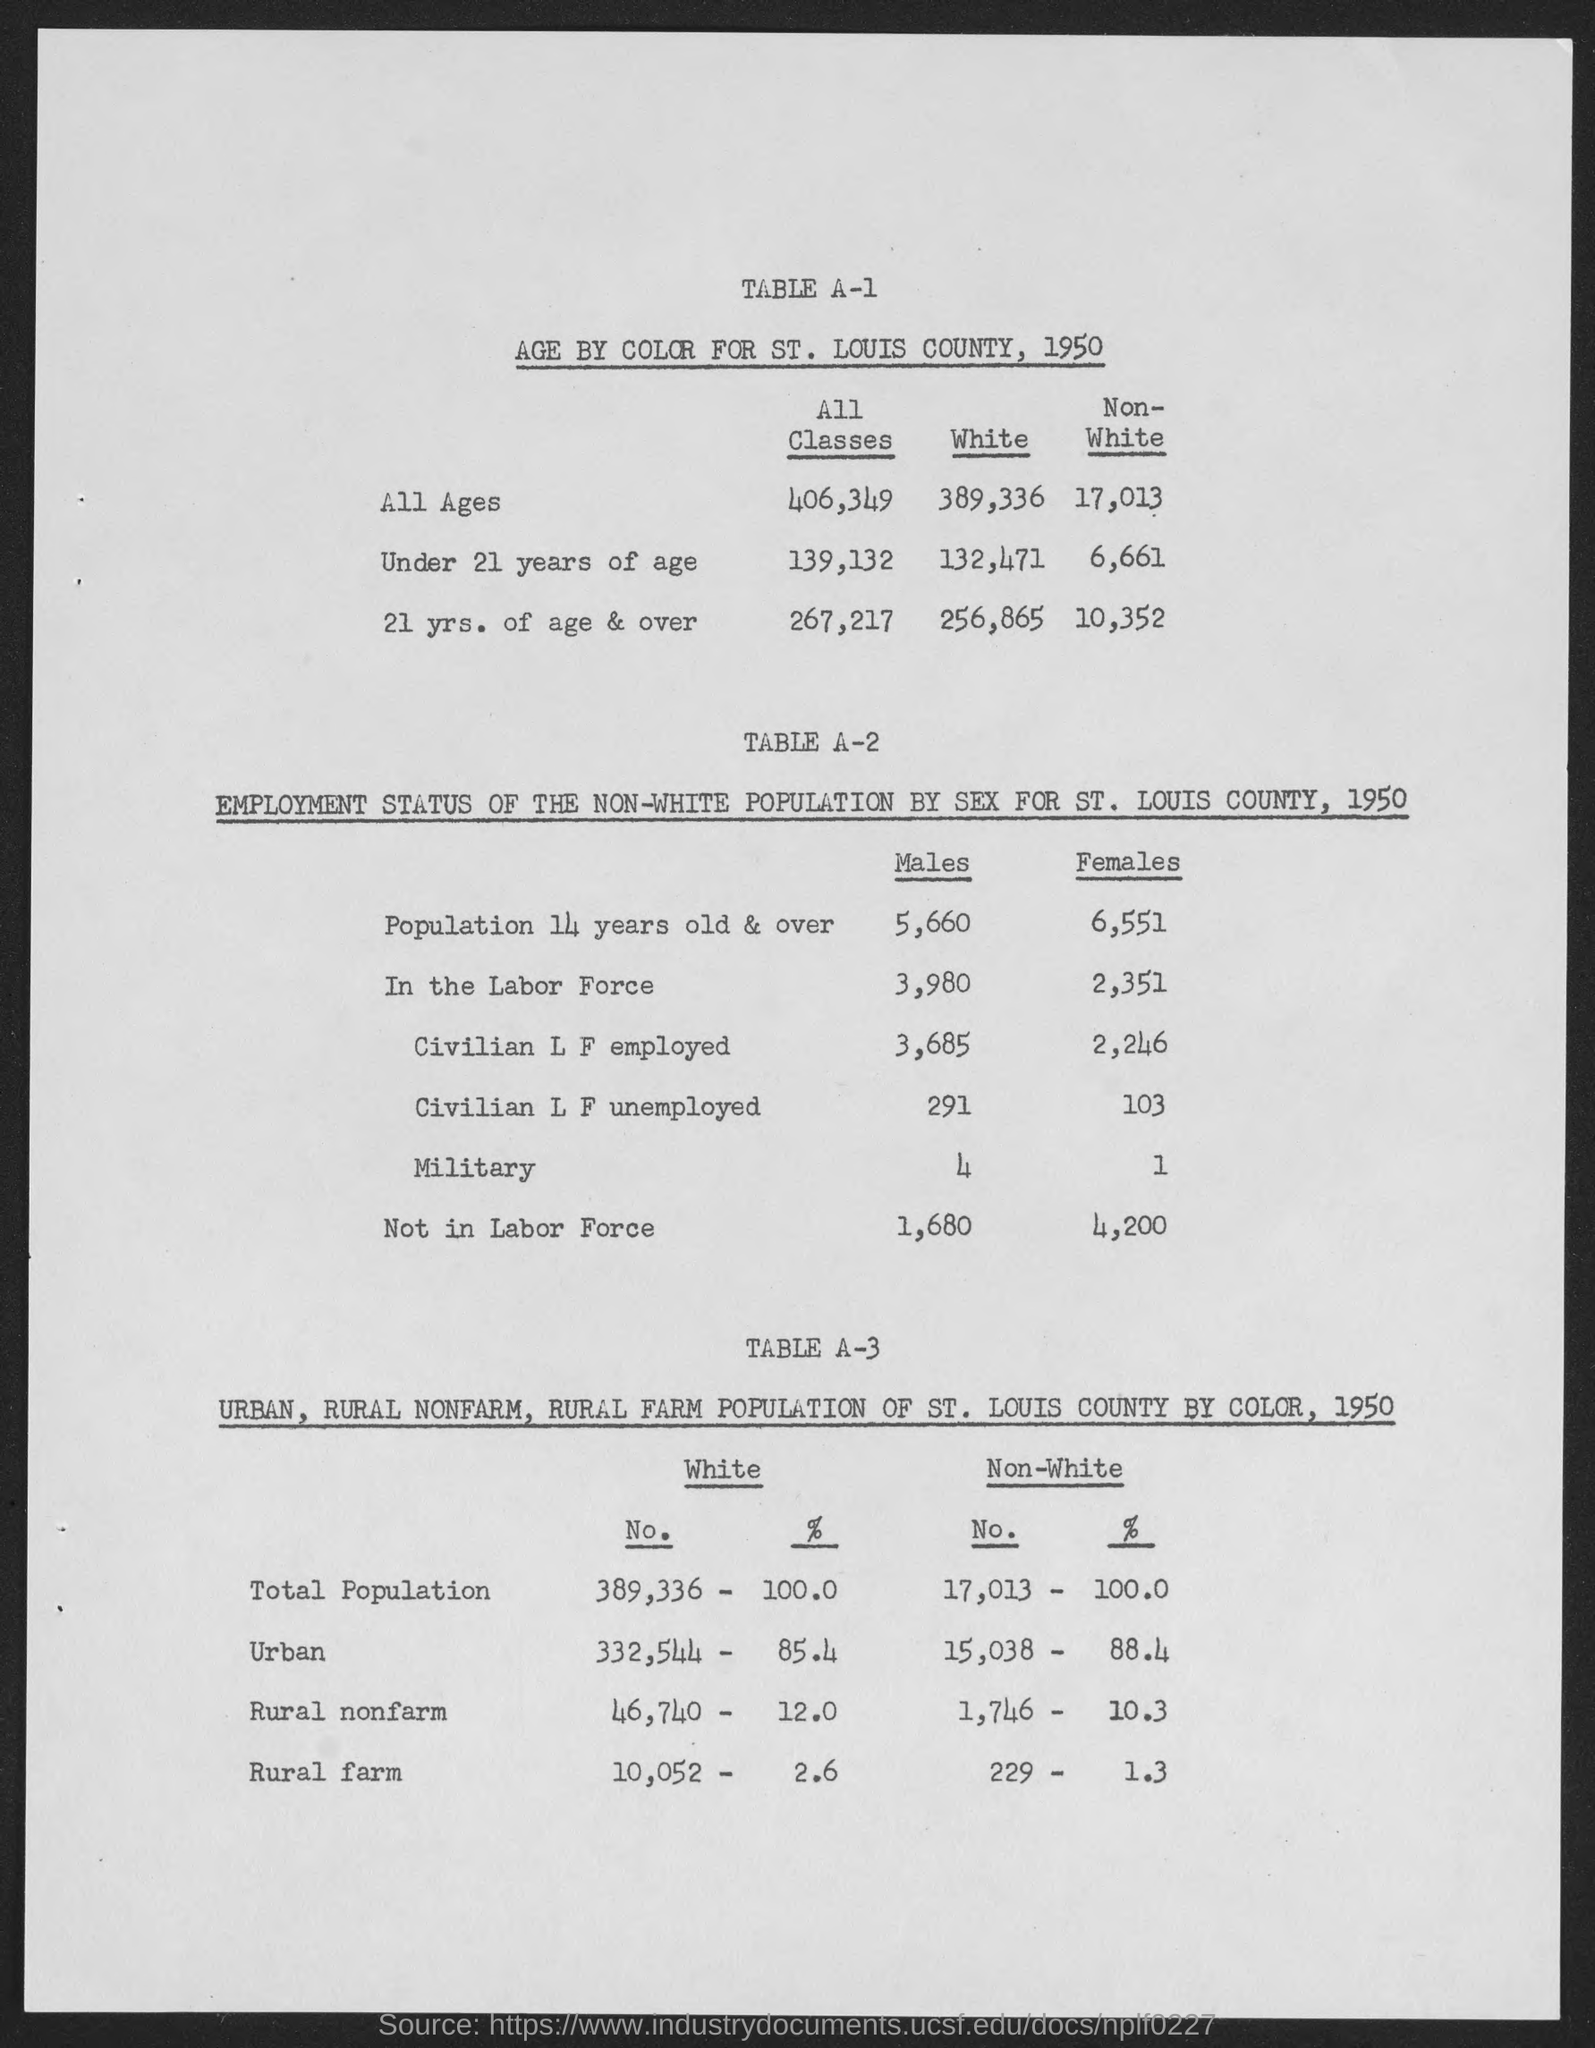Identify some key points in this picture. The age by color for St. Louis county in 1950 for all ages and all classes was 406,349. The age by color for St. Louis county for individuals under 21 years of age who are white was 132,471 in 1950. In the year 1950, the age of non-white individuals living in St. Louis county was calculated to be 17,013. In 1950, the number of non-white individuals under the age of 21 in St. Louis county who were recorded as being of a certain age by color was 6,661. In 1950, the age by color for St. Louis county for non-white individuals who were 21 years of age and over was 10,352. 